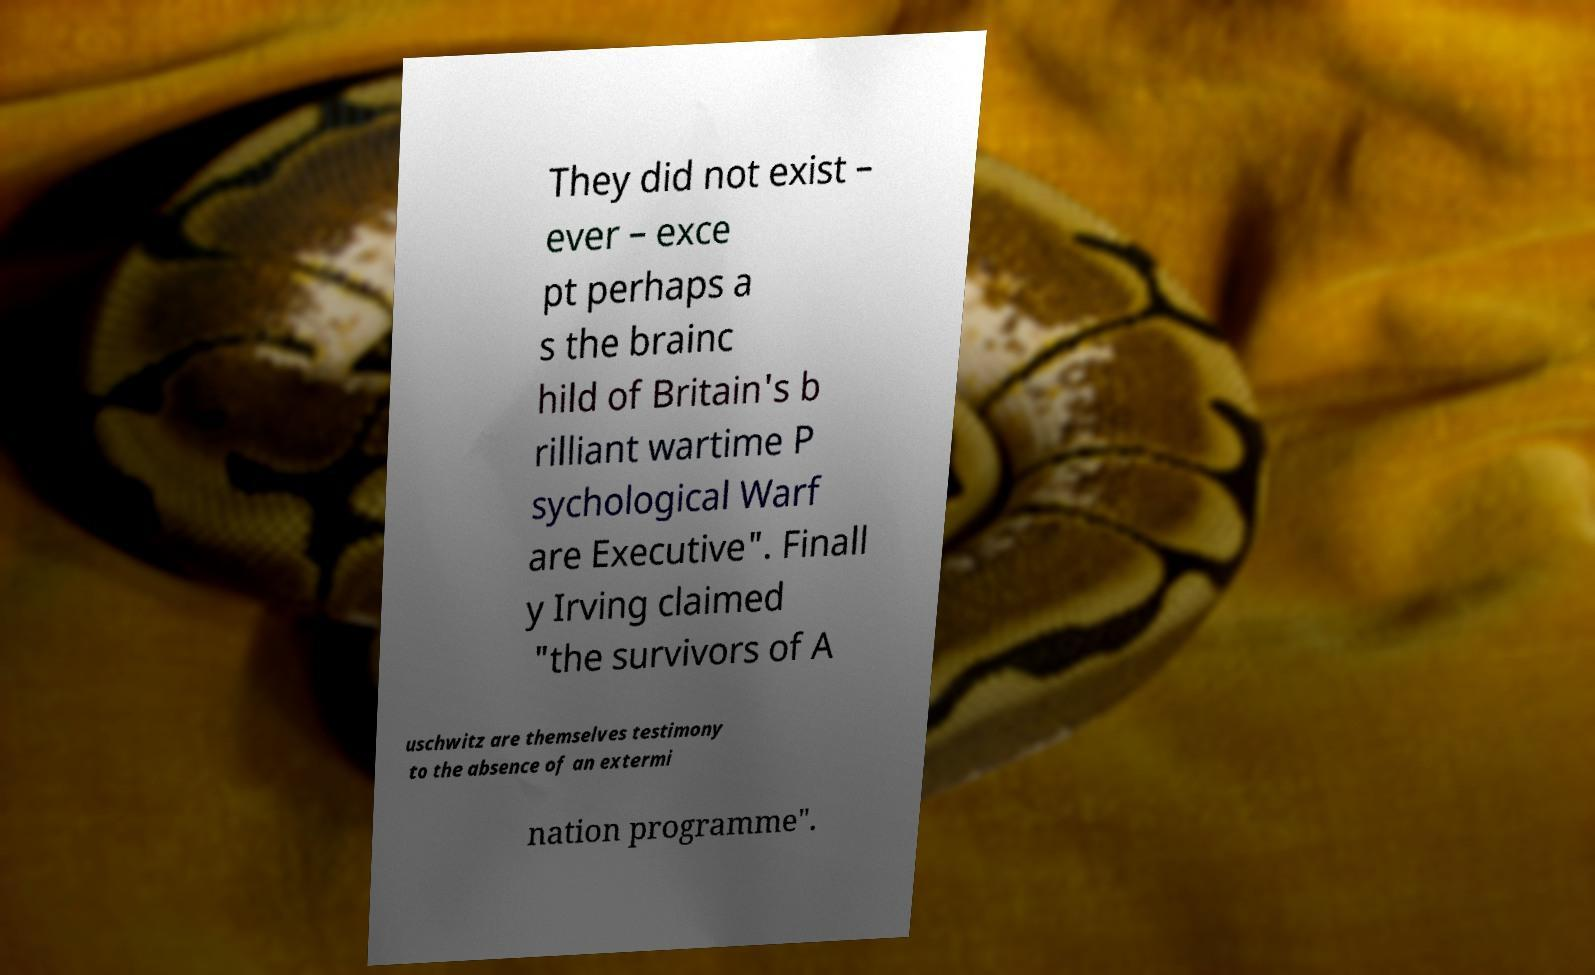Can you read and provide the text displayed in the image?This photo seems to have some interesting text. Can you extract and type it out for me? They did not exist – ever – exce pt perhaps a s the brainc hild of Britain's b rilliant wartime P sychological Warf are Executive". Finall y Irving claimed "the survivors of A uschwitz are themselves testimony to the absence of an extermi nation programme". 